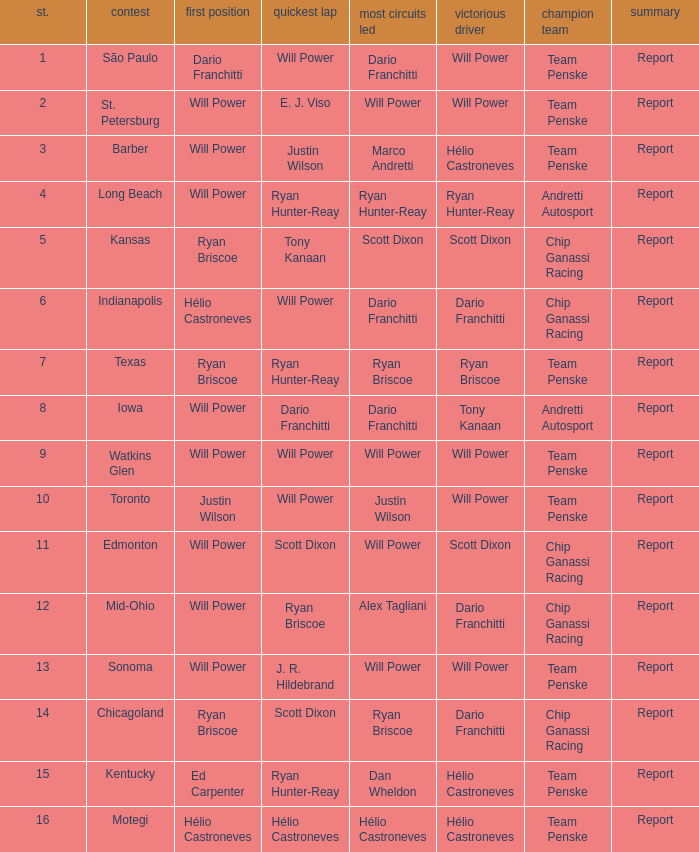In what position did the winning driver finish at Chicagoland? 1.0. 